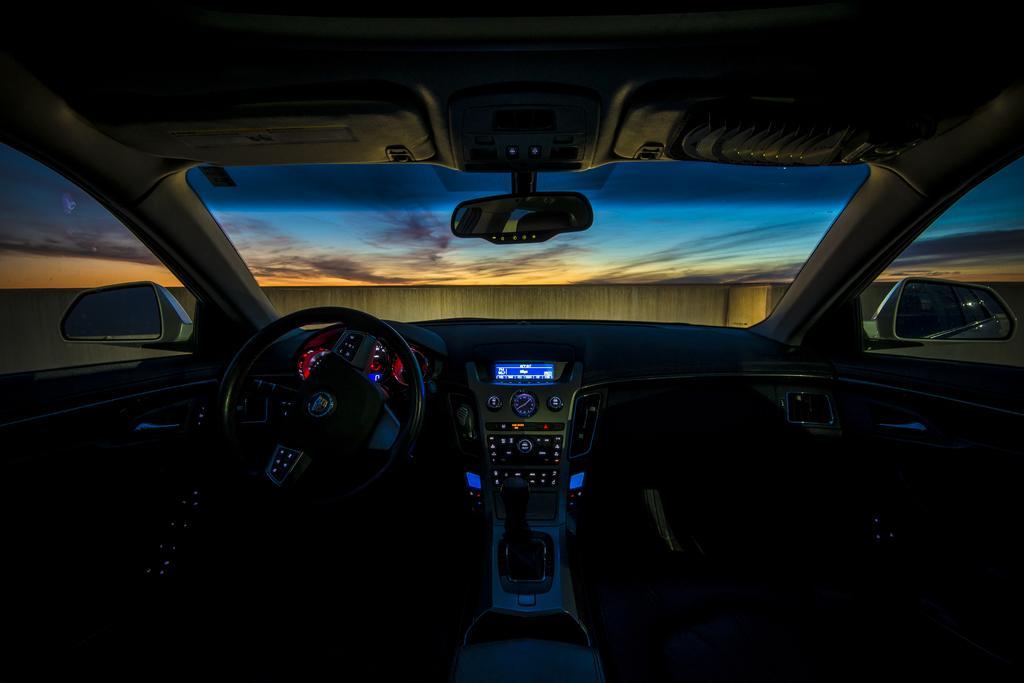Please provide a concise description of this image. In this picture we can see inside of a vehicle, here we can see a steering, speedometers, mirrors, windscreen wiper and some objects, from windscreen wiper we can see a wall, sky. 